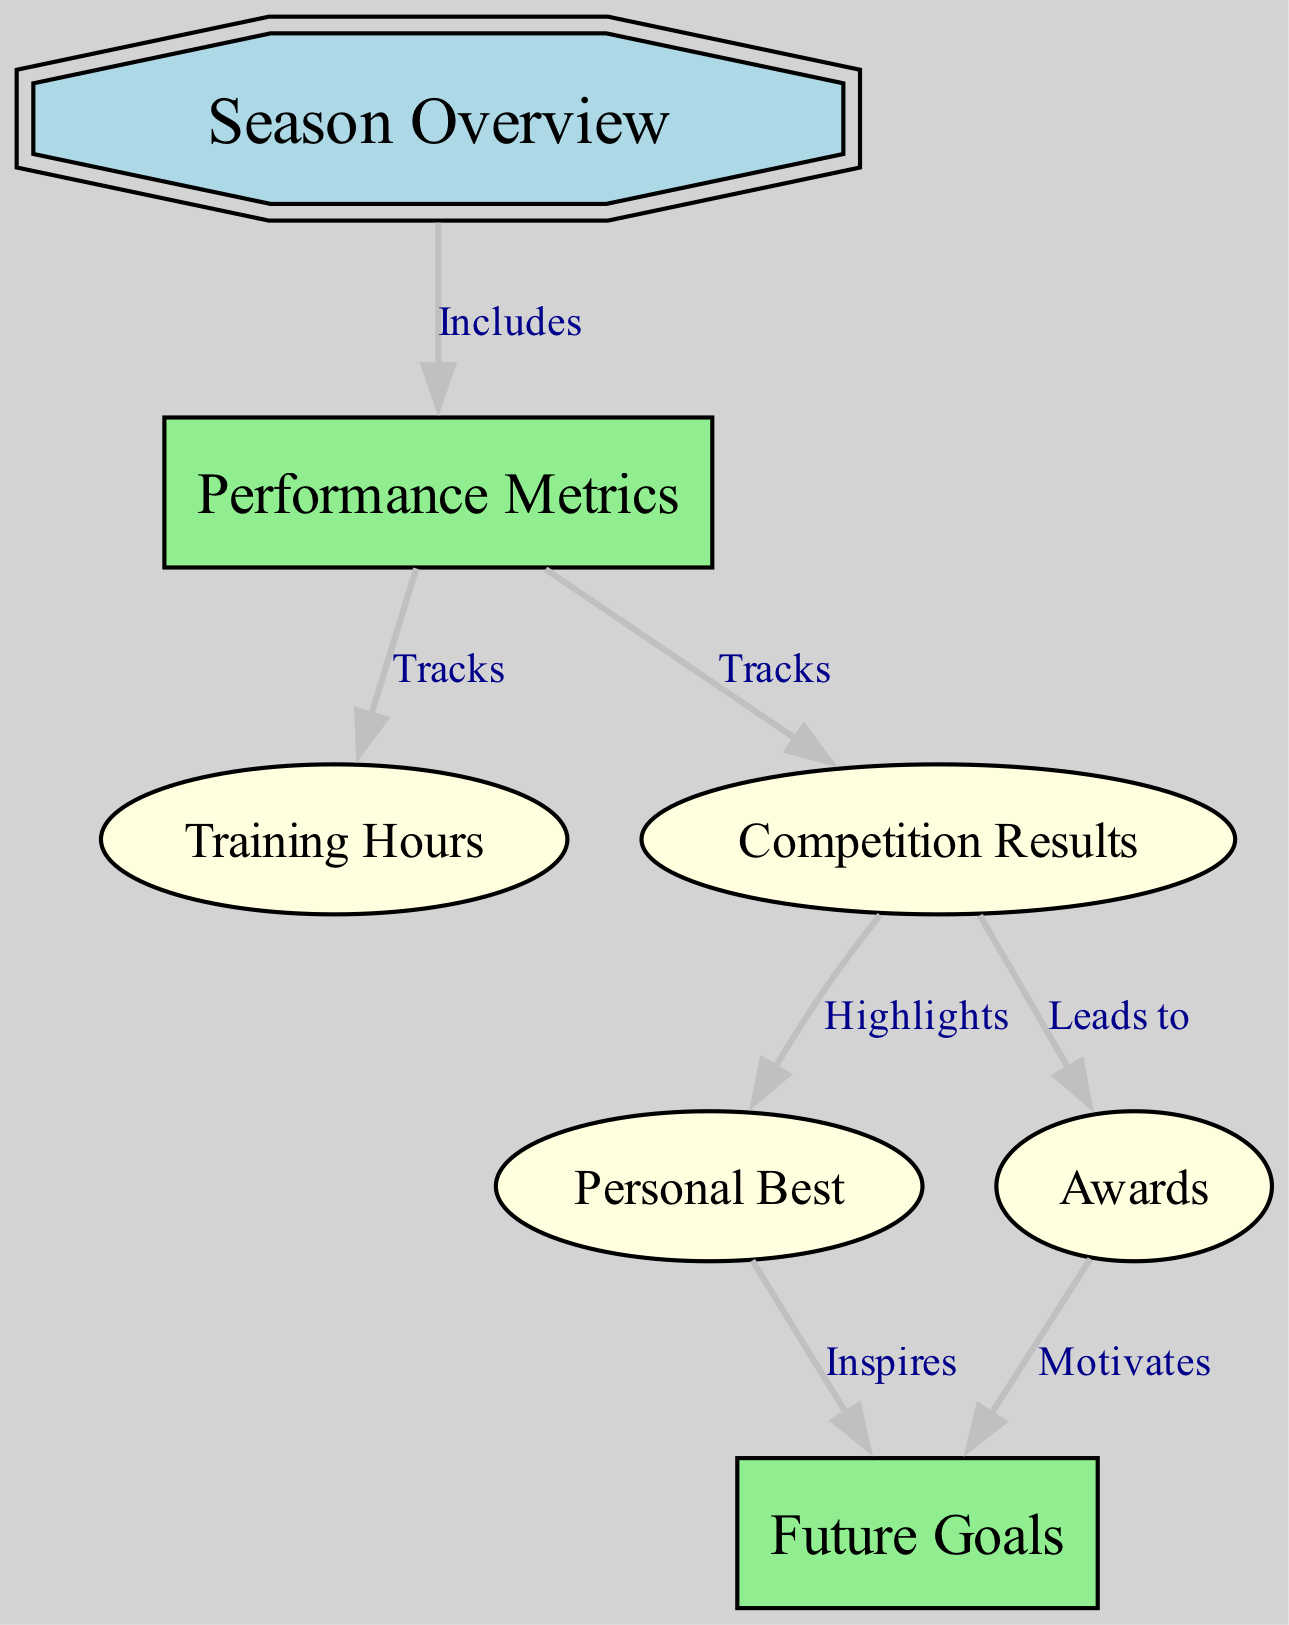What is the title of the diagram? The title of the diagram is provided at the top and is clearly labeled as "Seasonal Performance Analysis with Metrics and Achievements".
Answer: Seasonal Performance Analysis with Metrics and Achievements How many nodes are in the diagram? By counting the individual nodes listed in the data, there are a total of seven nodes.
Answer: 7 Which node represents the overall summary of the season? The node labeled "Season Overview" is identified as the overall summary of the season.
Answer: Season Overview What does the "Performance Metrics" node track? The "Performance Metrics" node tracks both "Training Hours" and "Competition Results" as indicated by the edges leading from it.
Answer: Training Hours and Competition Results What do "Personal Best" and "Awards" both connect to? Both the "Personal Best" and "Awards" nodes lead to the "Future Goals" node, showing their connection to future aspirations.
Answer: Future Goals Which node highlights achievements in competitions? The node labeled "Competition Results" highlights achievements in competitions, as specified in the diagram's edges.
Answer: Competition Results What inspires the "Future Goals"? The "Future Goals" node is inspired by the "Personal Best" achievements, indicating how past performance impacts future aspirations.
Answer: Personal Best Which nodes are motivated by "Awards"? The "Future Goals" node is motivated by the "Awards" node, signifying how recognition influences future ambitions.
Answer: Future Goals What relationship does "Competition Results" have with "Awards"? The "Competition Results" node leads to the "Awards" node, indicating that results from competitions can result in awards.
Answer: Leads to 